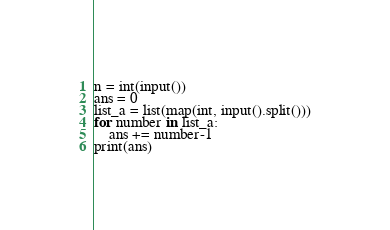Convert code to text. <code><loc_0><loc_0><loc_500><loc_500><_Python_>n = int(input())
ans = 0
list_a = list(map(int, input().split()))
for number in list_a:
    ans += number-1
print(ans)
</code> 